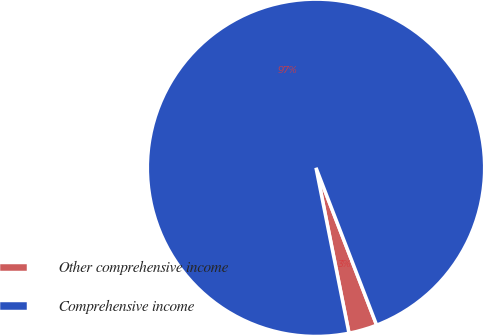<chart> <loc_0><loc_0><loc_500><loc_500><pie_chart><fcel>Other comprehensive income<fcel>Comprehensive income<nl><fcel>2.72%<fcel>97.28%<nl></chart> 